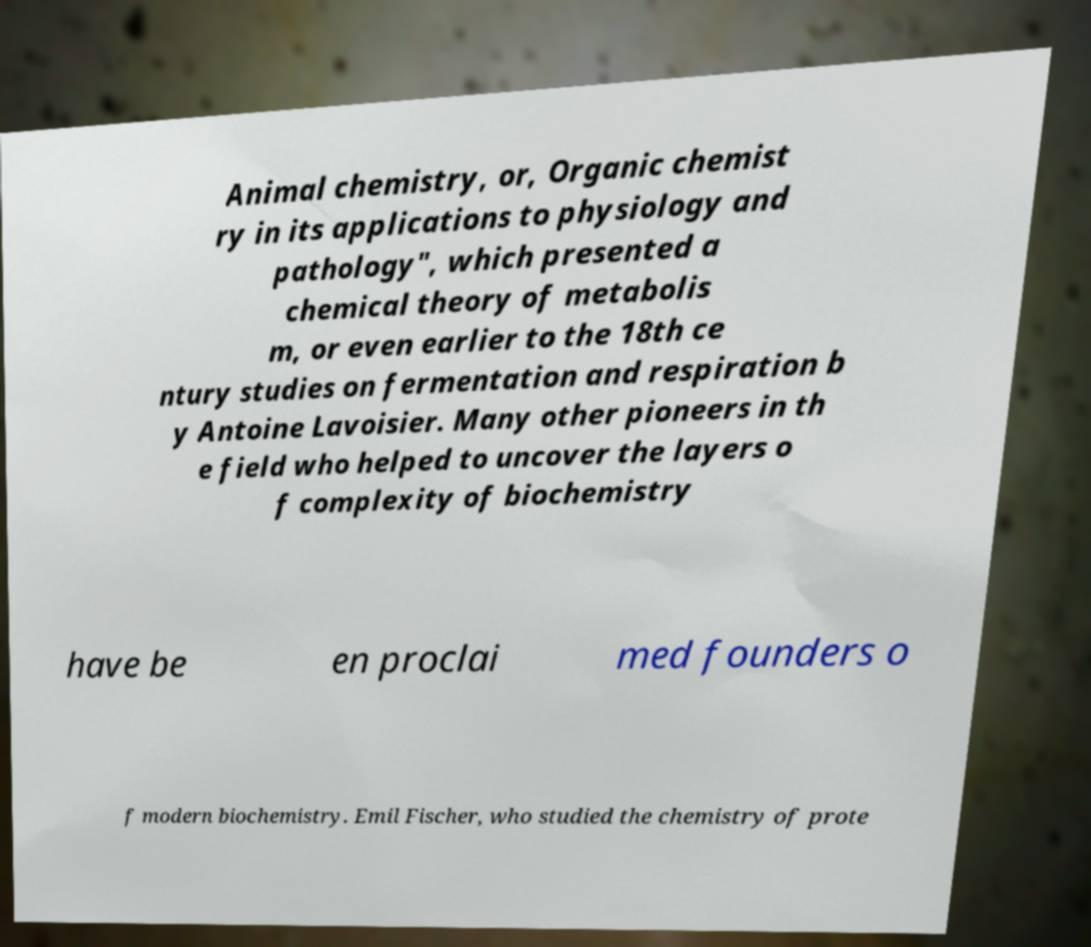For documentation purposes, I need the text within this image transcribed. Could you provide that? Animal chemistry, or, Organic chemist ry in its applications to physiology and pathology", which presented a chemical theory of metabolis m, or even earlier to the 18th ce ntury studies on fermentation and respiration b y Antoine Lavoisier. Many other pioneers in th e field who helped to uncover the layers o f complexity of biochemistry have be en proclai med founders o f modern biochemistry. Emil Fischer, who studied the chemistry of prote 